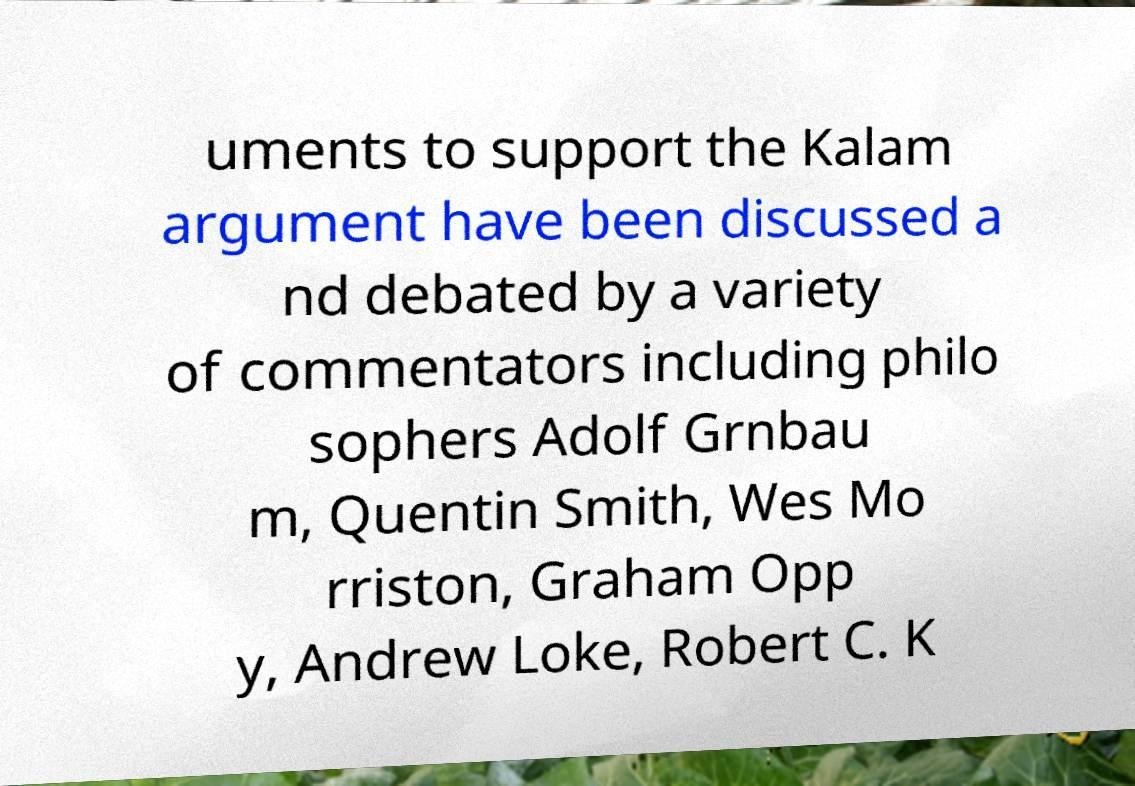Could you assist in decoding the text presented in this image and type it out clearly? uments to support the Kalam argument have been discussed a nd debated by a variety of commentators including philo sophers Adolf Grnbau m, Quentin Smith, Wes Mo rriston, Graham Opp y, Andrew Loke, Robert C. K 